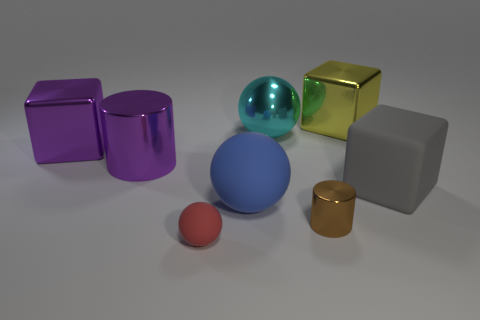Add 2 rubber things. How many objects exist? 10 Subtract all cylinders. How many objects are left? 6 Add 5 tiny shiny cylinders. How many tiny shiny cylinders are left? 6 Add 2 big red blocks. How many big red blocks exist? 2 Subtract 1 gray blocks. How many objects are left? 7 Subtract all purple cylinders. Subtract all large purple shiny cylinders. How many objects are left? 6 